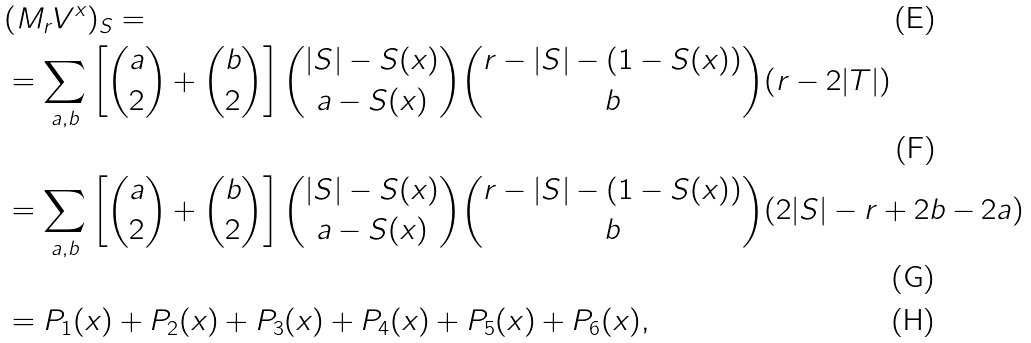Convert formula to latex. <formula><loc_0><loc_0><loc_500><loc_500>& ( M _ { r } { V } ^ { x } ) _ { S } = \\ & = \sum _ { a , b } \left [ \binom { a } { 2 } + \binom { b } { 2 } \right ] \binom { | S | - S ( x ) } { a - S ( x ) } \binom { r - | S | - ( 1 - S ( x ) ) } { b } ( r - 2 | T | ) \\ & = \sum _ { a , b } \left [ \binom { a } { 2 } + \binom { b } { 2 } \right ] \binom { | S | - S ( x ) } { a - S ( x ) } \binom { r - | S | - ( 1 - S ( x ) ) } { b } ( 2 | S | - r + 2 b - 2 a ) \\ & = P _ { 1 } ( x ) + P _ { 2 } ( x ) + P _ { 3 } ( x ) + P _ { 4 } ( x ) + P _ { 5 } ( x ) + P _ { 6 } ( x ) ,</formula> 